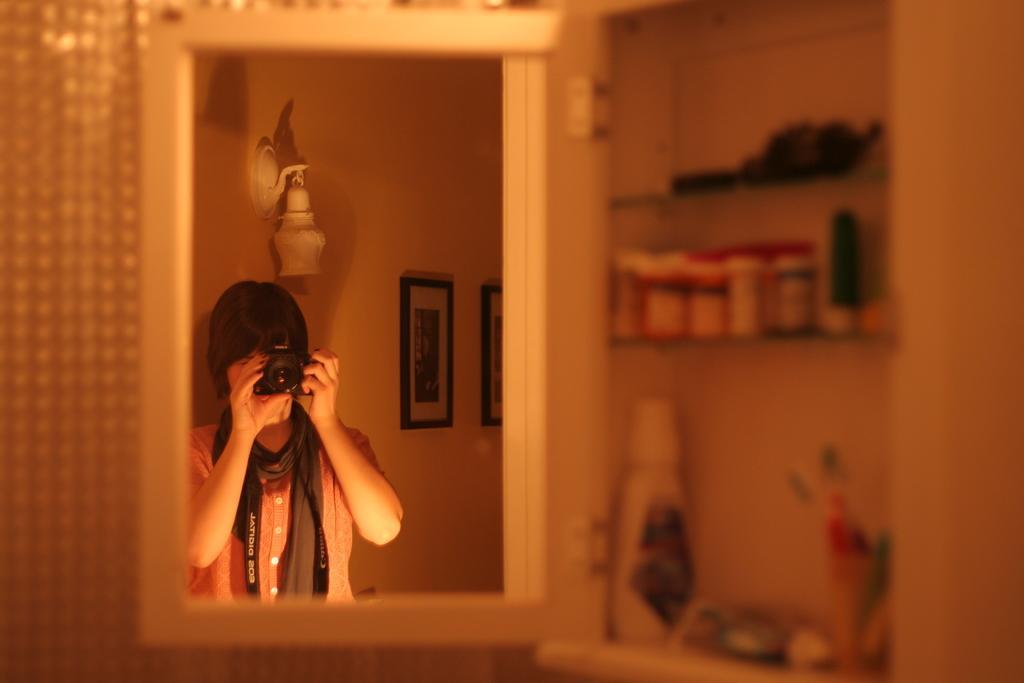Could you give a brief overview of what you see in this image? In the picture I can see a mirror on the left side. I can see the reflection of a person holding the camera. There are photo frames on the wall. I can see a few objects on the shelves on the right side. 